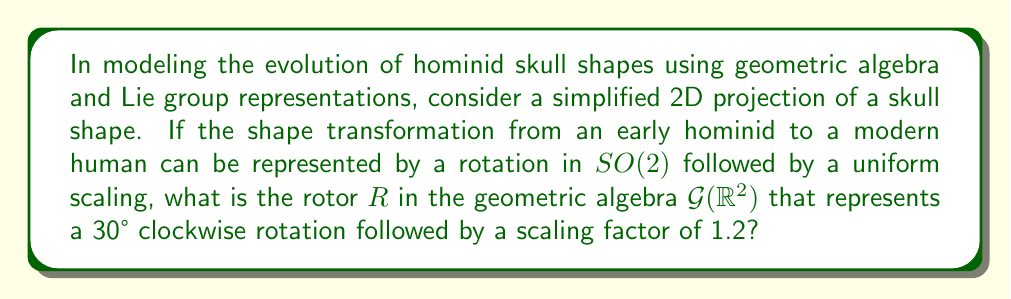Give your solution to this math problem. Let's approach this step-by-step:

1) In geometric algebra $\mathcal{G}(\mathbb{R}^2)$, a rotor $R$ representing a rotation by angle $\theta$ is given by:

   $R = e^{-\frac{\theta}{2}e_{12}} = \cos(\frac{\theta}{2}) - e_{12}\sin(\frac{\theta}{2})$

   where $e_{12}$ is the unit bivector.

2) For a 30° clockwise rotation, $\theta = -30° = -\frac{\pi}{6}$ radians. Substituting:

   $R_{rotation} = \cos(-\frac{\pi}{12}) - e_{12}\sin(-\frac{\pi}{12})$
                 $= \cos(\frac{\pi}{12}) + e_{12}\sin(\frac{\pi}{12})$

3) Using a calculator or known values:

   $R_{rotation} = \frac{\sqrt{6}+\sqrt{2}}{4} + e_{12}\frac{\sqrt{6}-\sqrt{2}}{4}$

4) A uniform scaling by a factor $k$ is represented in geometric algebra by the scalar $k$. Here, $k = 1.2$.

5) The complete transformation is the composition of rotation followed by scaling. In geometric algebra, this is represented by the product of the scaling factor and the rotation rotor:

   $R = 1.2 \cdot R_{rotation}$

6) Therefore, the final rotor $R$ is:

   $R = 1.2 \cdot (\frac{\sqrt{6}+\sqrt{2}}{4} + e_{12}\frac{\sqrt{6}-\sqrt{2}}{4})$

7) Simplifying:

   $R = 0.3(\sqrt{6}+\sqrt{2}) + 0.3e_{12}(\sqrt{6}-\sqrt{2})$

This rotor $R$ represents the combined transformation of rotation and scaling in the geometric algebra $\mathcal{G}(\mathbb{R}^2)$.
Answer: $R = 0.3(\sqrt{6}+\sqrt{2}) + 0.3e_{12}(\sqrt{6}-\sqrt{2})$ 